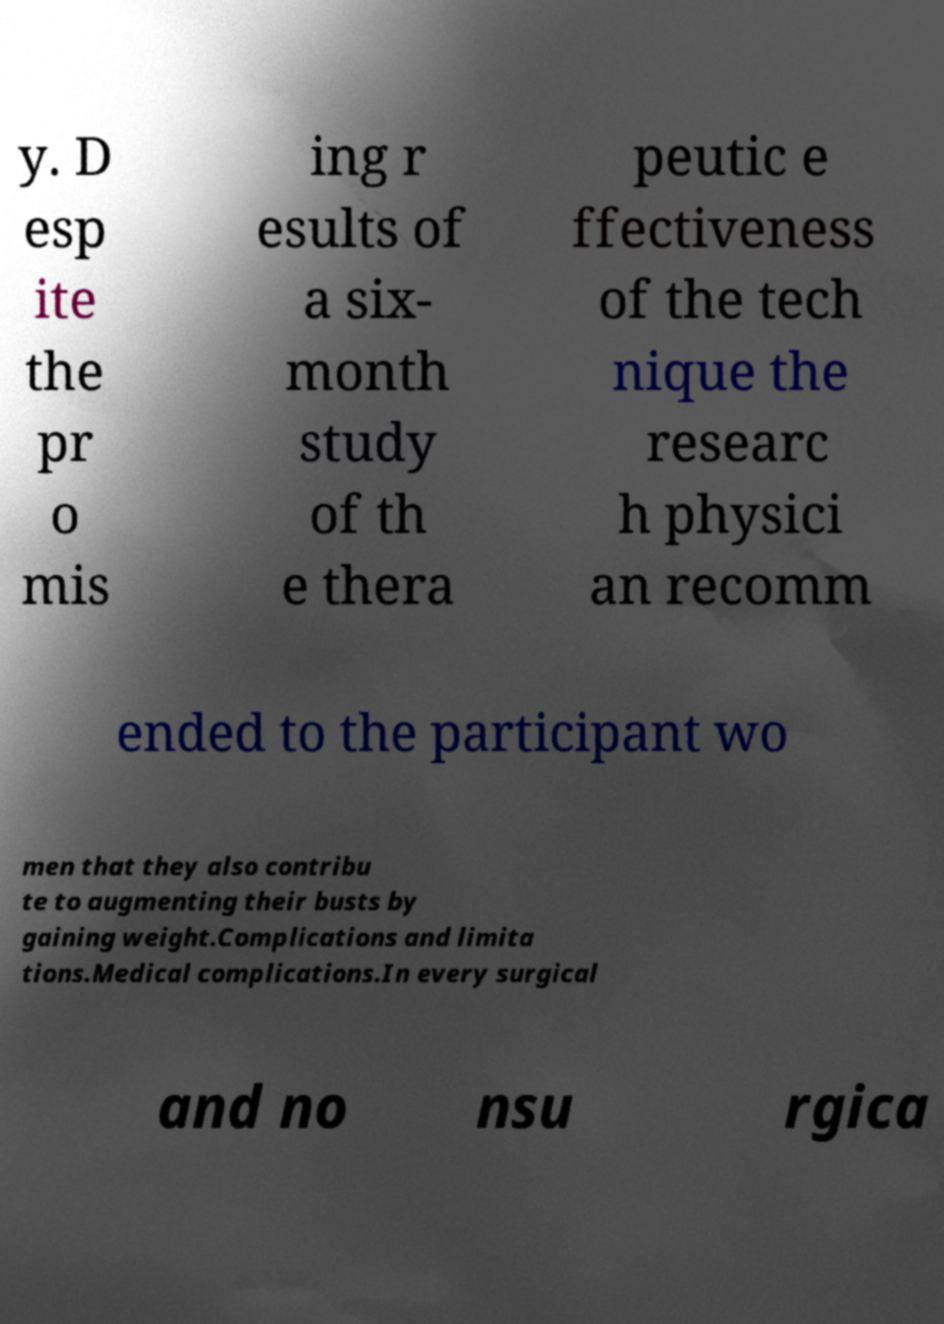Please read and relay the text visible in this image. What does it say? y. D esp ite the pr o mis ing r esults of a six- month study of th e thera peutic e ffectiveness of the tech nique the researc h physici an recomm ended to the participant wo men that they also contribu te to augmenting their busts by gaining weight.Complications and limita tions.Medical complications.In every surgical and no nsu rgica 